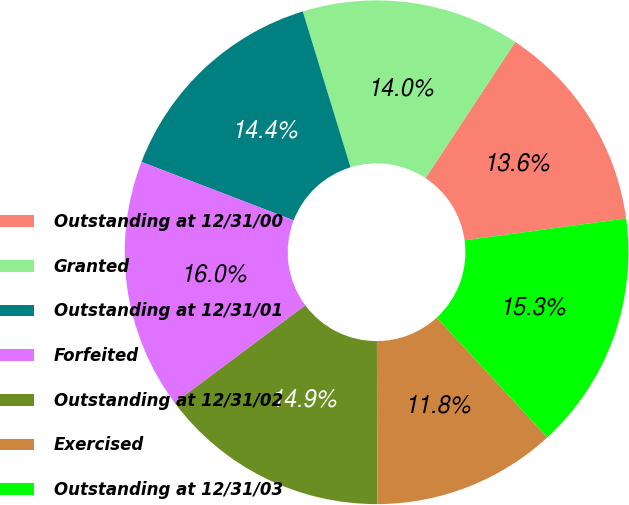Convert chart to OTSL. <chart><loc_0><loc_0><loc_500><loc_500><pie_chart><fcel>Outstanding at 12/31/00<fcel>Granted<fcel>Outstanding at 12/31/01<fcel>Forfeited<fcel>Outstanding at 12/31/02<fcel>Exercised<fcel>Outstanding at 12/31/03<nl><fcel>13.58%<fcel>14.01%<fcel>14.43%<fcel>16.04%<fcel>14.86%<fcel>11.79%<fcel>15.29%<nl></chart> 